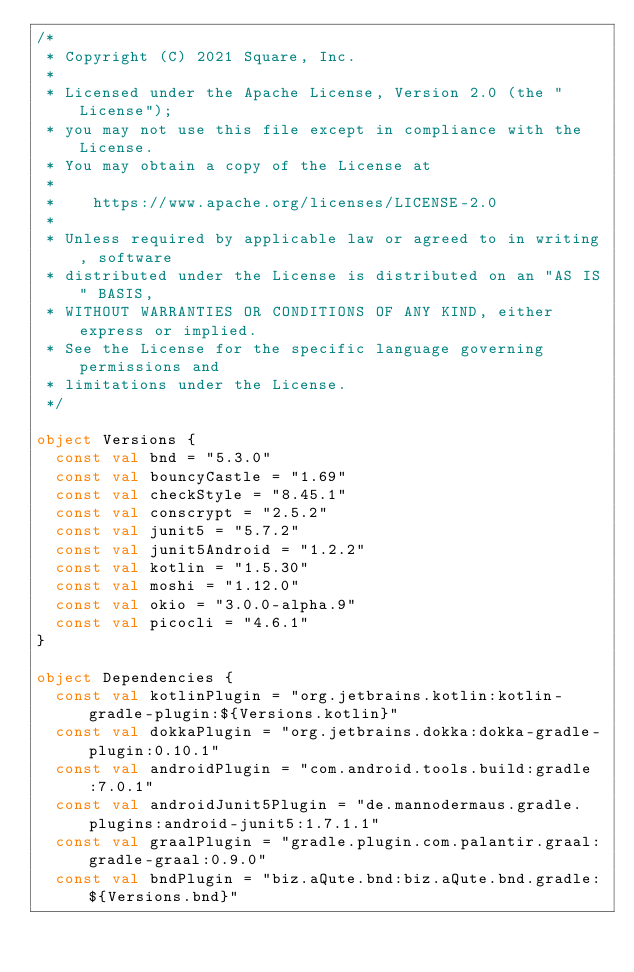<code> <loc_0><loc_0><loc_500><loc_500><_Kotlin_>/*
 * Copyright (C) 2021 Square, Inc.
 *
 * Licensed under the Apache License, Version 2.0 (the "License");
 * you may not use this file except in compliance with the License.
 * You may obtain a copy of the License at
 *
 *    https://www.apache.org/licenses/LICENSE-2.0
 *
 * Unless required by applicable law or agreed to in writing, software
 * distributed under the License is distributed on an "AS IS" BASIS,
 * WITHOUT WARRANTIES OR CONDITIONS OF ANY KIND, either express or implied.
 * See the License for the specific language governing permissions and
 * limitations under the License.
 */

object Versions {
  const val bnd = "5.3.0"
  const val bouncyCastle = "1.69"
  const val checkStyle = "8.45.1"
  const val conscrypt = "2.5.2"
  const val junit5 = "5.7.2"
  const val junit5Android = "1.2.2"
  const val kotlin = "1.5.30"
  const val moshi = "1.12.0"
  const val okio = "3.0.0-alpha.9"
  const val picocli = "4.6.1"
}

object Dependencies {
  const val kotlinPlugin = "org.jetbrains.kotlin:kotlin-gradle-plugin:${Versions.kotlin}"
  const val dokkaPlugin = "org.jetbrains.dokka:dokka-gradle-plugin:0.10.1"
  const val androidPlugin = "com.android.tools.build:gradle:7.0.1"
  const val androidJunit5Plugin = "de.mannodermaus.gradle.plugins:android-junit5:1.7.1.1"
  const val graalPlugin = "gradle.plugin.com.palantir.graal:gradle-graal:0.9.0"
  const val bndPlugin = "biz.aQute.bnd:biz.aQute.bnd.gradle:${Versions.bnd}"</code> 